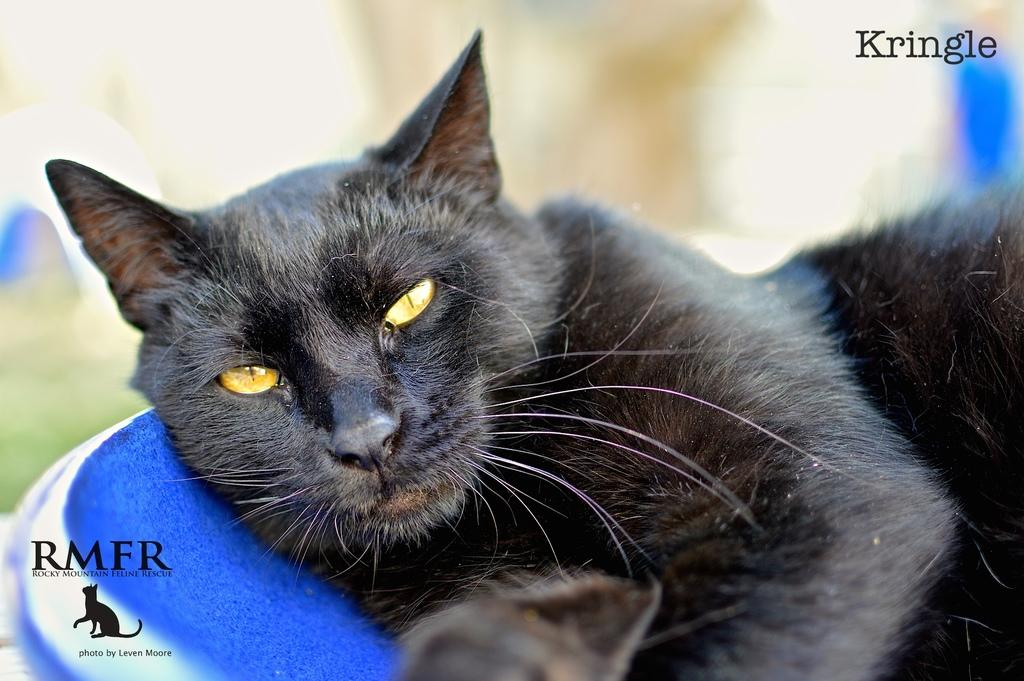What type of animal is in the image? There is a cat in the image. What can be found in the bottom left corner of the image? There is a logo and text in the bottom left of the image. Where is the text located in the image? There is text in the top right of the image. What type of plate is being used by the cat in the image? There is no plate present in the image; it features a cat and text. Can you see the moon in the image? The moon is not visible in the image. 